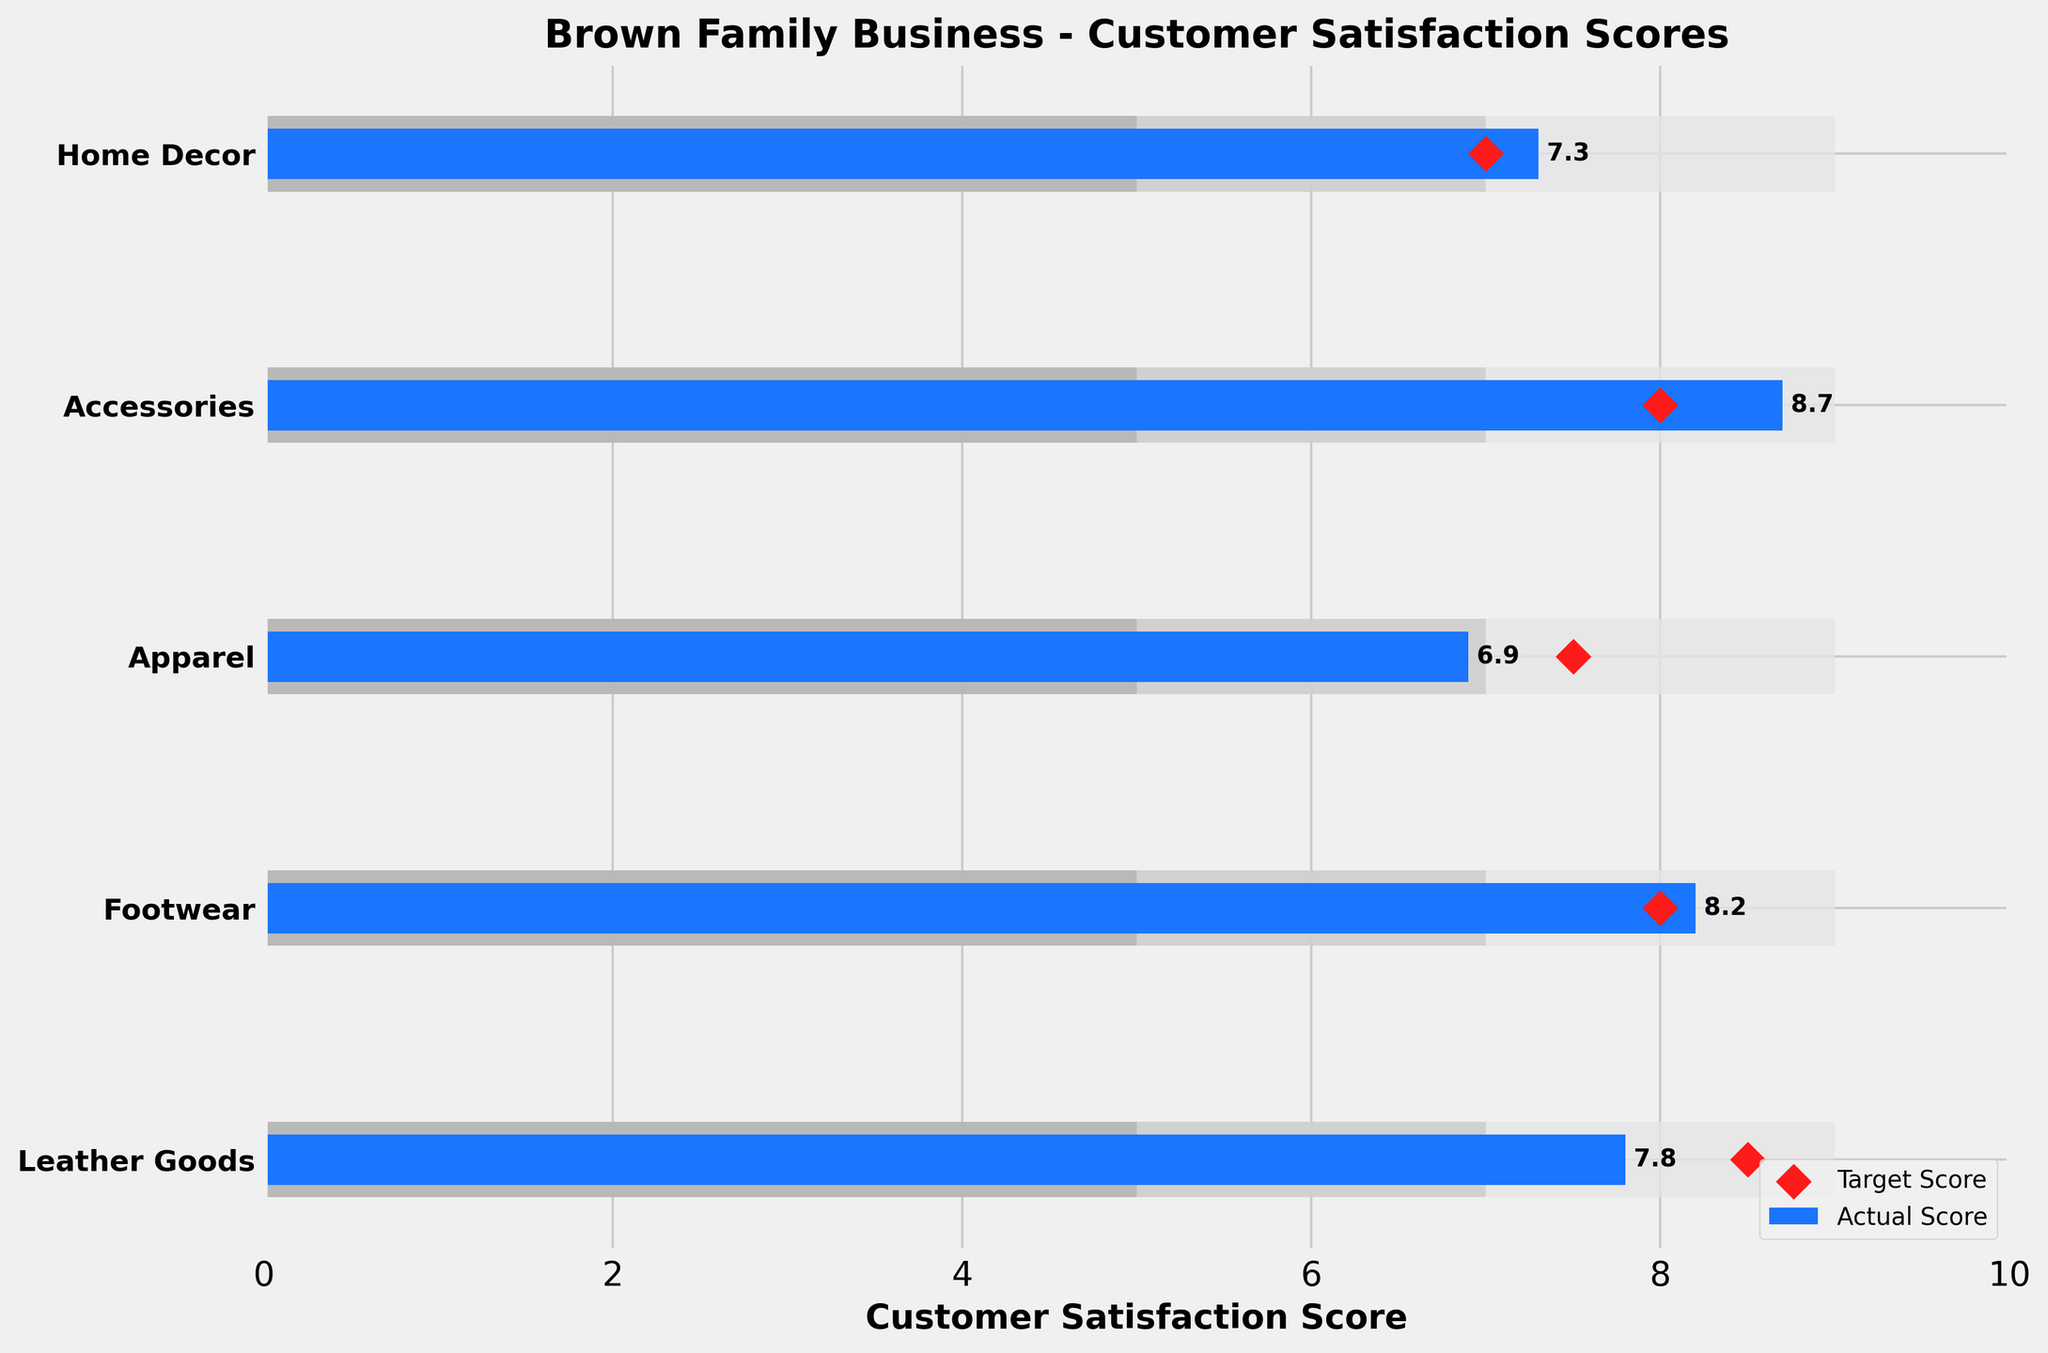What is the title of the figure? The title is displayed at the top of the chart and is meant to summarize the subject of the plot. Here, the title is "Brown Family Business - Customer Satisfaction Scores".
Answer: Brown Family Business - Customer Satisfaction Scores What color represents the actual scores in the figure? The color used for the actual scores can be identified by looking at the legend at the lower right of the chart. The legend indicates that the actual scores are represented by a blue bar.
Answer: Blue Which product line has the highest actual satisfaction score? To find this, look at the blue bars and identify the longest one. The Accessories product line has the highest actual satisfaction score with an 8.7.
Answer: Accessories Is the target score for Footwear higher than the actual score for Apparel? The target score for Footwear can be identified by the red diamond symbol. Footwear's target score is 8.0, which is higher than Apparel's actual score of 6.9.
Answer: Yes How many product lines have actual scores above their target scores? Compare the lengths of the blue bars (actual scores) with the positions of the red diamonds (target scores). Leather Goods and Apparel have actual scores below their target scores. Footwear, Accessories, and Home Decor have actual scores above their target scores.
Answer: 3 Which product line has the largest difference between its actual score and target score? Calculate the difference for each product line by subtracting the target score from the actual score and find the maximum difference. Accessories has the largest difference (8.7 - 8.0 = 0.7).
Answer: Accessories What is the range for satisfactory scores? The range for satisfactory scores can be identified by its labeling on the bar. It spans from 5 to 7.
Answer: 5 to 7 Which product lines fall into the 'Good' range? The 'Good' range is from 7 to 9. Identify the blue bars (actual scores) that fall within this range. Leather Goods, Footwear, and Home Decor fall into this range.
Answer: Leather Goods, Footwear, Home Decor How many product lines have their actual scores in the 'Excellent' range? The 'Excellent' range starts at 9.0 and above. Identify the blue bars that reach or exceed this range. There are no product lines in this range.
Answer: 0 What is the average actual satisfaction score across all product lines? Sum all actual scores (7.8 + 8.2 + 6.9 + 8.7 + 7.3 = 38.9) and divide by the number of product lines (5). The average is 38.9 / 5.
Answer: 7.78 